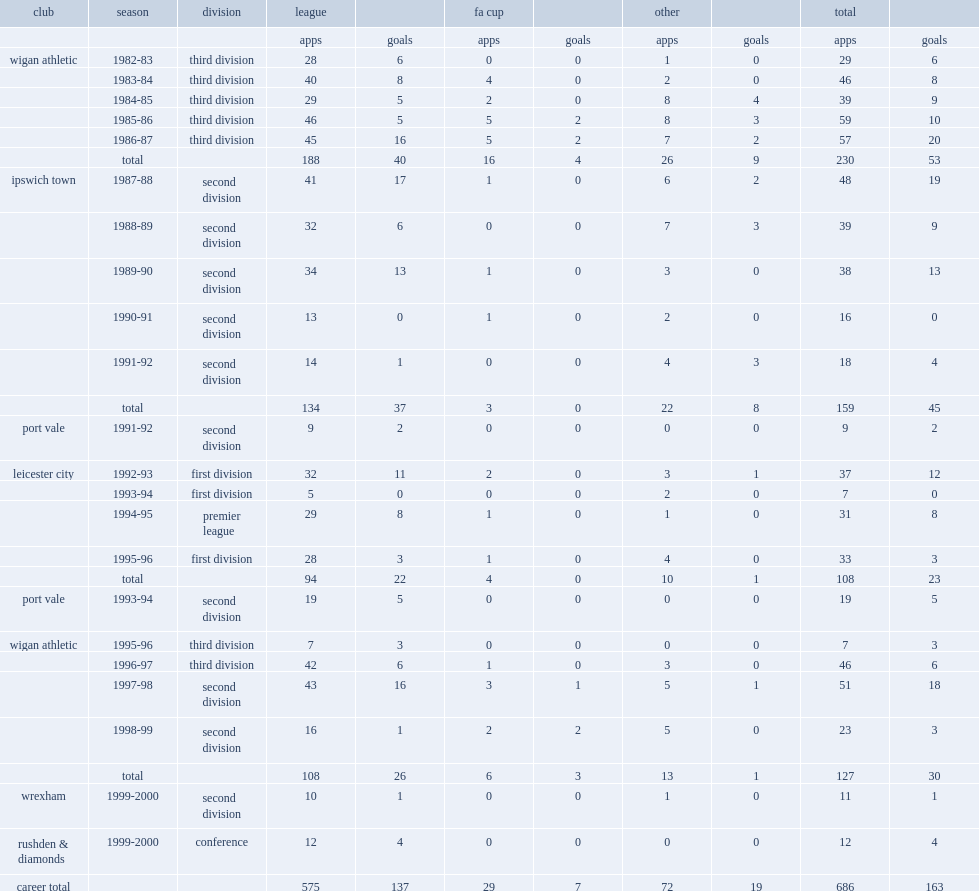What club did david lowe play for in the 1996-97 season? Wigan athletic. 